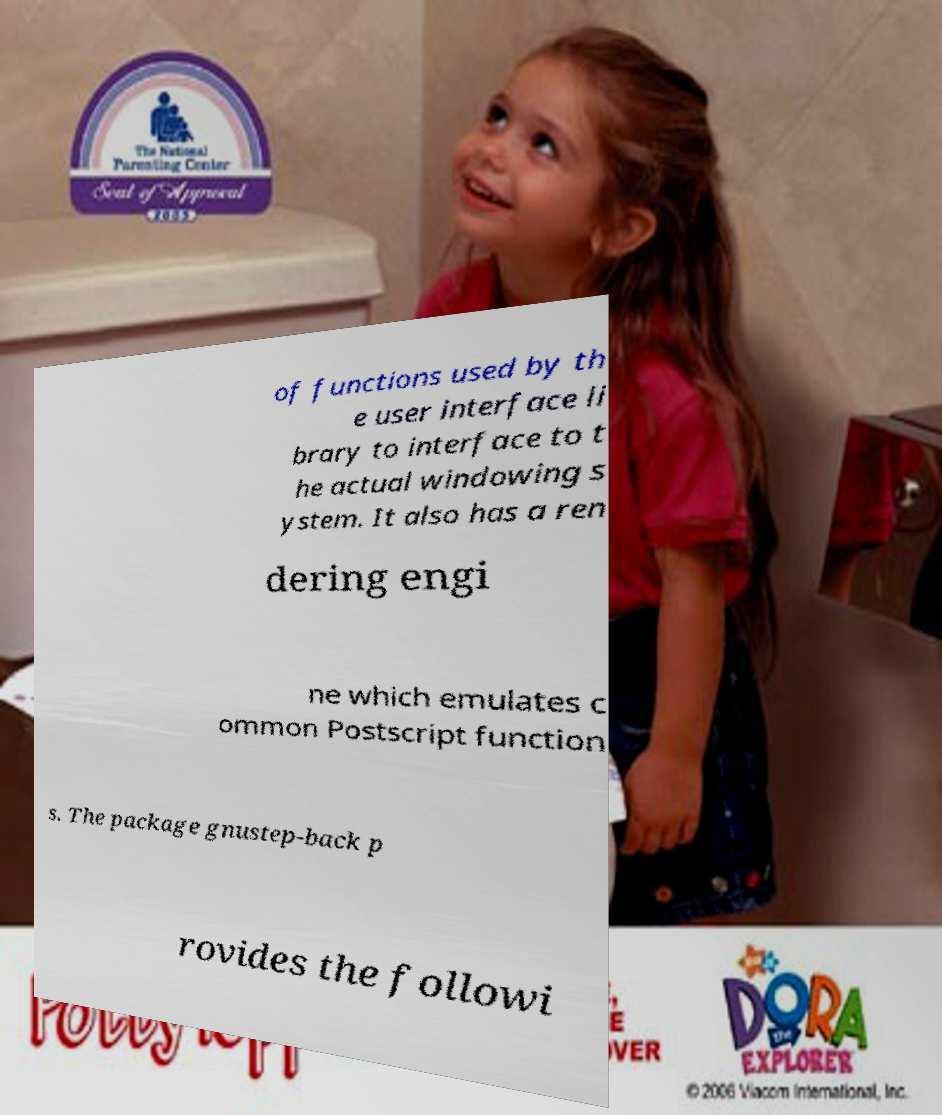For documentation purposes, I need the text within this image transcribed. Could you provide that? of functions used by th e user interface li brary to interface to t he actual windowing s ystem. It also has a ren dering engi ne which emulates c ommon Postscript function s. The package gnustep-back p rovides the followi 